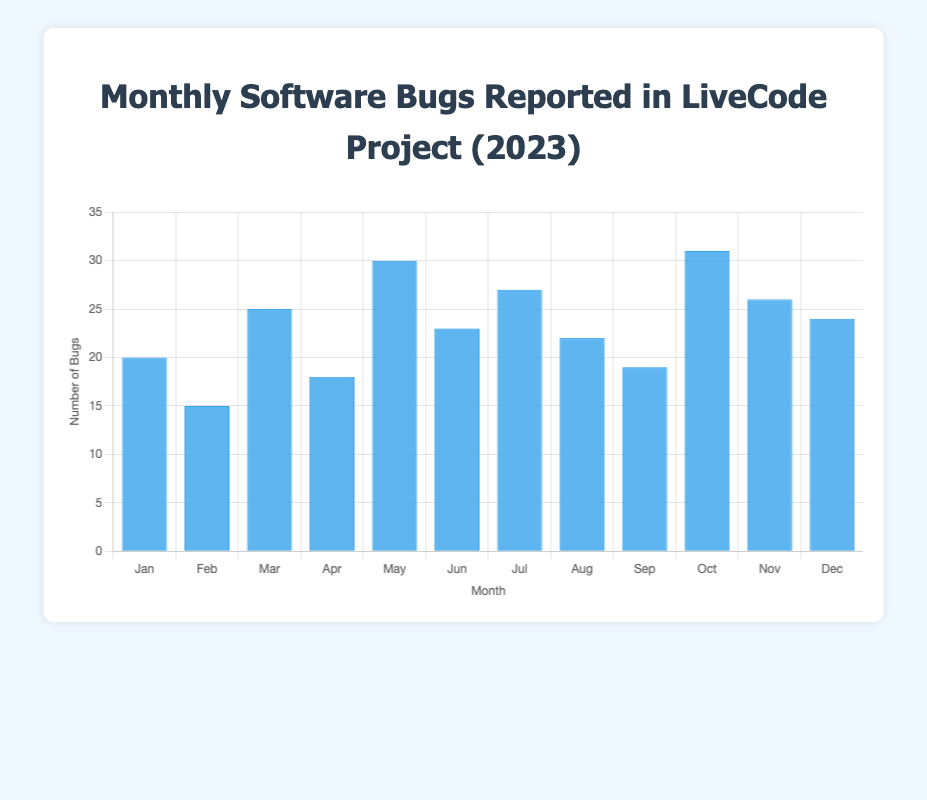What's the highest number of bugs reported in a single month? To find the highest number of bugs, look for the tallest bar in the chart. The bar representing October is the tallest, indicating the highest value of 31 bugs.
Answer: 31 Which month had fewer bugs reported: April or August? Compare the heights of the bars for April and August. April's bar (18 bugs) is shorter than August's bar (22 bugs). So, April had fewer bugs reported.
Answer: April What is the average number of bugs reported per month? Sum all the bugs reported over the year and divide by the number of months. (20 + 15 + 25 + 18 + 30 + 23 + 27 + 22 + 19 + 31 + 26 + 24) = 280. Divide 280 by 12 months to get the average.
Answer: 23.33 By how much did the number of bugs reported increase from February to March? Subtract the number of bugs reported in February (15) from the number of bugs reported in March (25). The difference is 25 - 15 = 10.
Answer: 10 Which month experienced the largest decrease in the number of bugs reported compared to the previous month? Calculate the decrease for each month by subtracting the current month's bugs from the previous month's bugs. Look for the largest negative difference: Jan to Feb (20-15 = 5), Feb to Mar (15-25 = -10), Mar to Apr (25-18 = 7), Apr to May (18-30 = -12), May to Jun (30-23 = 7), Jun to Jul (23-27 = -4), Jul to Aug (27-22 = 5), Aug to Sep (22-19 = 3), Sep to Oct (19-31 = -12), Oct to Nov (31-26 = 5), Nov to Dec (26-24 = 2). The largest decrease is from May to June with a drop of 12.
Answer: May to June Which three consecutive months had the highest total number of bugs? Add the bugs for each set of consecutive three months: 
1. Jan-Feb-Mar: 20+15+25 = 60
2. Feb-Mar-Apr: 15+25+18 = 58
3. Mar-Apr-May: 25+18+30 = 73
4. Apr-May-Jun: 18+30+23 = 71
5. May-Jun-Jul: 30+23+27 = 80
6. Jun-Jul-Aug: 23+27+22 = 72
7. Jul-Aug-Sep: 27+22+19 = 68
8. Aug-Sep-Oct: 22+19+31 = 72
9. Sep-Oct-Nov: 19+31+26 = 76
10. Oct-Nov-Dec: 31+26+24 = 81 
The highest total is in Oct-Nov-Dec with 81 bugs.
Answer: October to December Which quarter of the year had the fewest bugs reported? Sum the bugs for each quarter: 
1. Q1 (Jan-Mar): 20+15+25 = 60
2. Q2 (Apr-Jun): 18+30+23 = 71
3. Q3 (Jul-Sep): 27+22+19 = 68
4. Q4 (Oct-Dec): 31+26+24 = 81 
Q1 had the fewest with 60 bugs.
Answer: Q1 What is the difference in the number of bugs between the month with the highest number and the month with the lowest number? Identify the highest (October with 31 bugs) and the lowest (February with 15 bugs) values. The difference is 31 - 15 = 16.
Answer: 16 